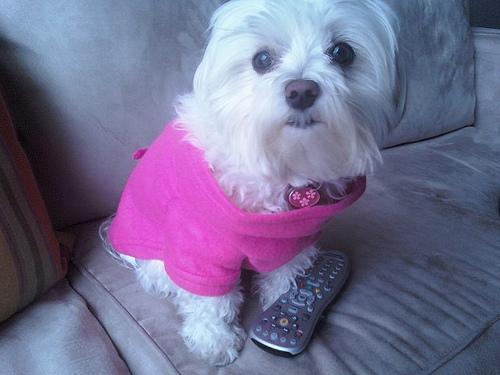What is this dog wearing?
Be succinct. Sweater. Is the dog's hair long or short?
Keep it brief. Long. Is the dog wearing an ID?
Concise answer only. Yes. Is this a pampered animal?
Short answer required. Yes. What color are the dog's ears?
Short answer required. White. Is the dog warm?
Concise answer only. Yes. What is the dog doing?
Short answer required. Sitting. What color is the chair cover?
Concise answer only. Tan. 